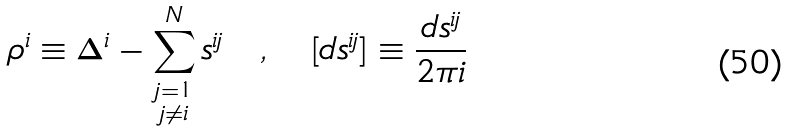Convert formula to latex. <formula><loc_0><loc_0><loc_500><loc_500>\rho ^ { i } \equiv \Delta ^ { i } - \sum _ { \substack { j = { 1 } \\ j \not = i } } ^ { N } s ^ { i j } \quad , \quad [ d s ^ { i j } ] \equiv \frac { d s ^ { i j } } { 2 \pi i }</formula> 